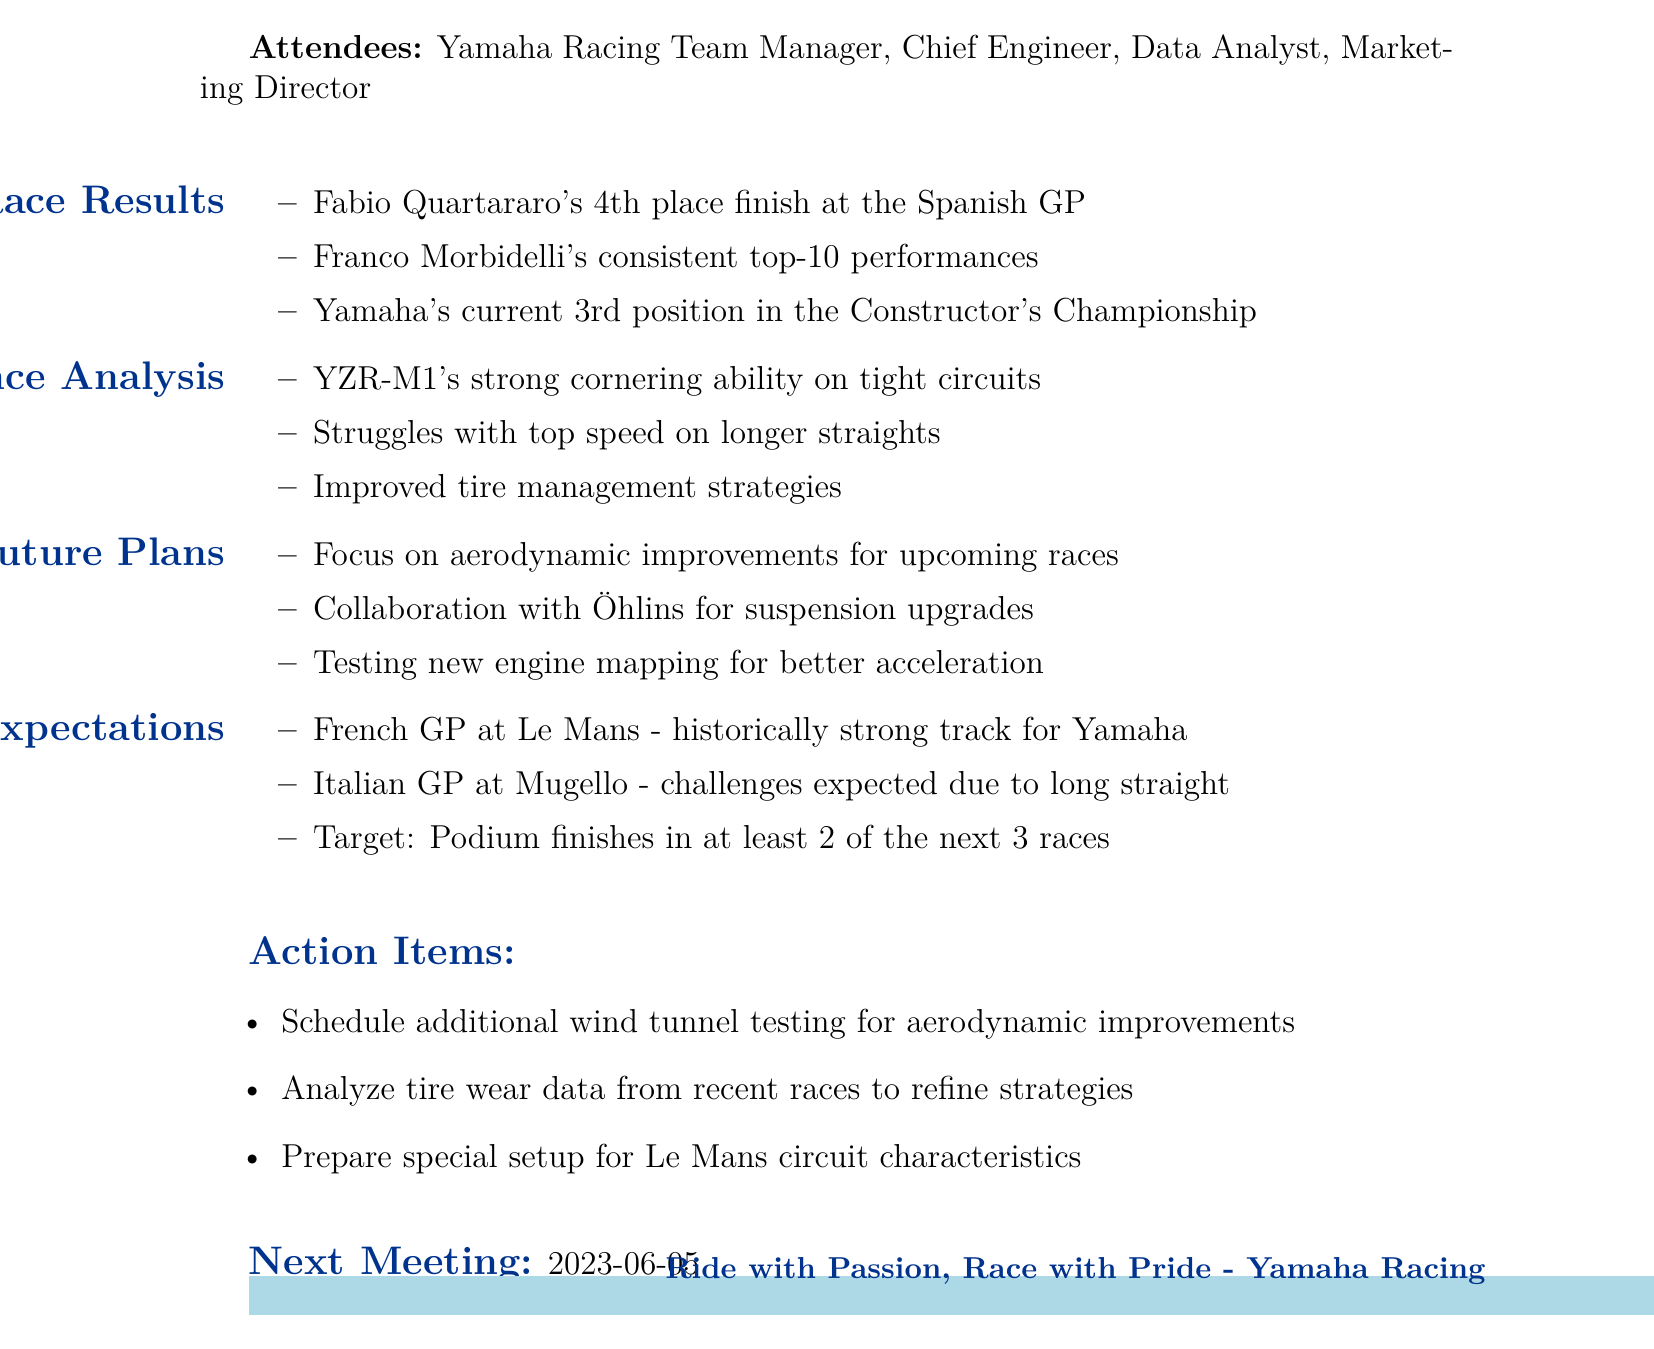What was Fabio Quartararo's finishing position at the Spanish GP? Fabio Quartararo finished in 4th place at the Spanish Grand Prix, as stated in the results section.
Answer: 4th place What is Yamaha's current position in the Constructor's Championship? The document indicates that Yamaha is currently in 3rd position in the Constructor's Championship.
Answer: 3rd position What are the upcoming races mentioned in the minutes? The document lists the French GP at Le Mans and the Italian GP at Mugello as upcoming races for the Yamaha team.
Answer: French GP at Le Mans, Italian GP at Mugello What specific improvements is the team focusing on for future races? The agenda highlights a focus on aerodynamic improvements as a strategy for upcoming races.
Answer: Aerodynamic improvements What collaboration is mentioned in the team strategies? The document notes collaboration with Öhlins for suspension upgrades as part of the team's strategies.
Answer: Öhlins What is the target for podium finishes in the next three races? The minutes state that the target is to achieve podium finishes in at least 2 of the next 3 races.
Answer: 2 of the next 3 races What is one of the action items for the team? One action item listed is to analyze tire wear data from recent races to refine strategies.
Answer: Analyze tire wear data When is the next meeting scheduled? The next meeting is scheduled for June 5, 2023, as indicated in the document.
Answer: 2023-06-05 